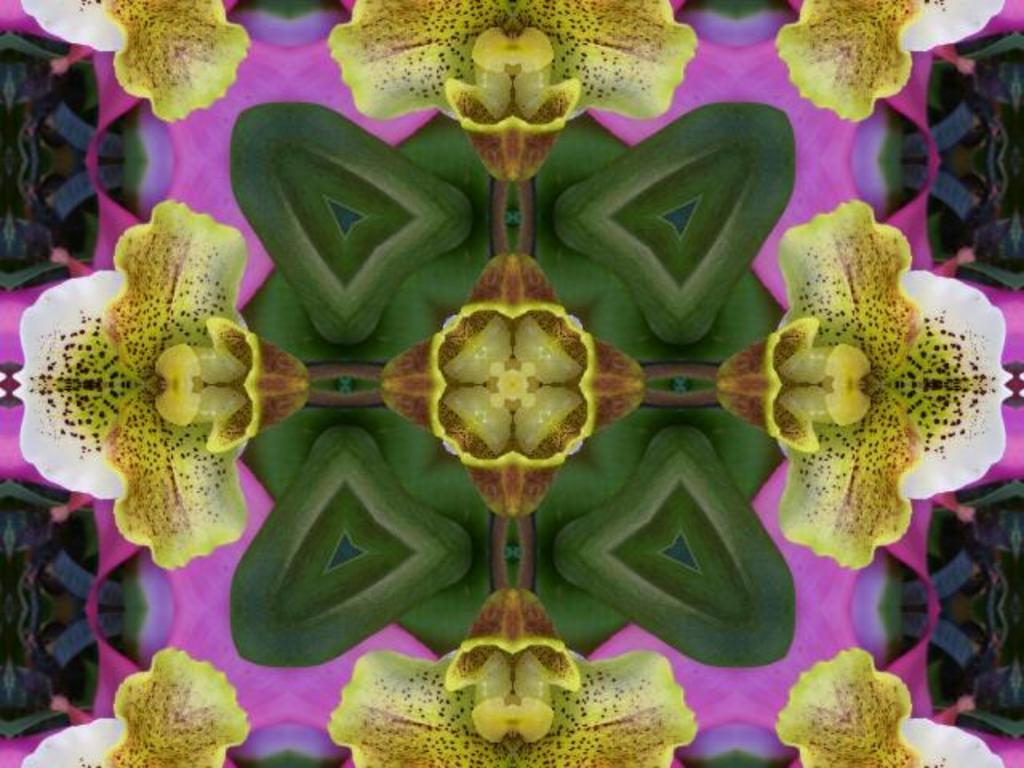What type of plant can be seen in the image? There are flowers in the image. What are the main features of the flowers? The flowers have petals and green leaves. What type of winter clothing is visible in the image? There is no winter clothing present in the image; it features flowers with petals and green leaves. 